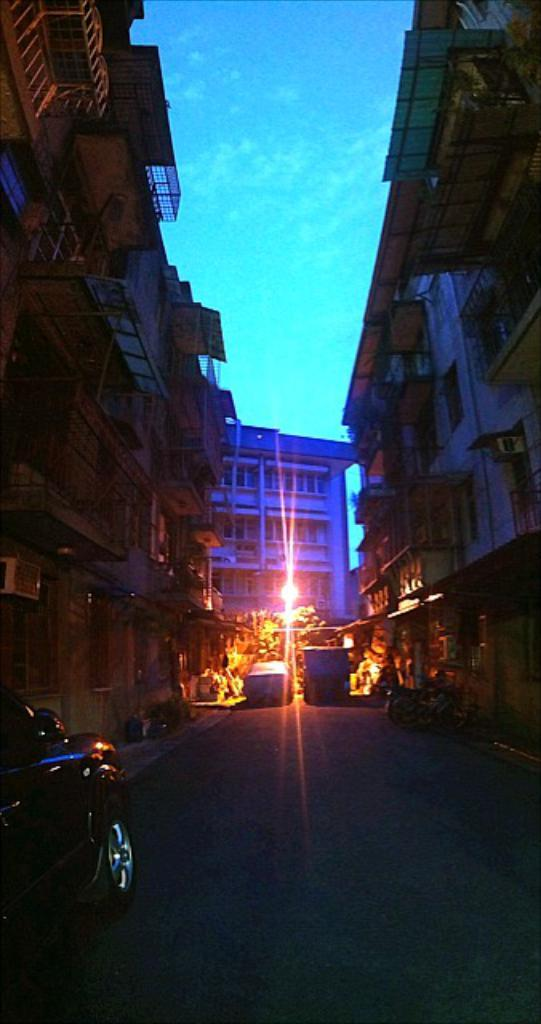What type of structures can be seen in the image? There are buildings in the image. What mode of transportation is visible in the image? There are cars and a motorcycle in the image. Can you describe the vehicle parked in the image? There is a vehicle parked in the image, but the specific type is not mentioned. What color is the sky in the image? The sky is blue in the image. Where is the tiger sitting on the shelf in the image? There is no tiger or shelf present in the image. What type of nut is being used to fuel the motorcycle in the image? There is no mention of a nut being used to fuel the motorcycle in the image. 